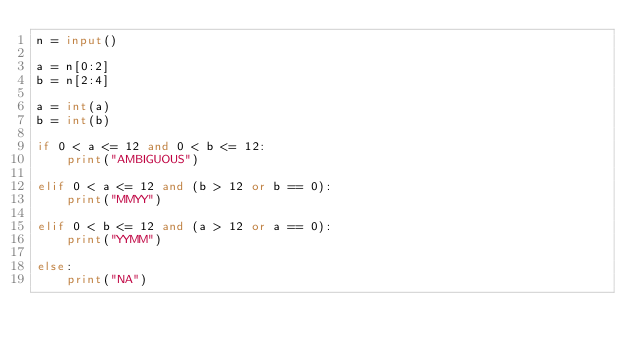Convert code to text. <code><loc_0><loc_0><loc_500><loc_500><_Python_>n = input()

a = n[0:2]
b = n[2:4]

a = int(a)
b = int(b)

if 0 < a <= 12 and 0 < b <= 12:
    print("AMBIGUOUS")

elif 0 < a <= 12 and (b > 12 or b == 0):
    print("MMYY")

elif 0 < b <= 12 and (a > 12 or a == 0):
    print("YYMM")

else:
    print("NA")
</code> 